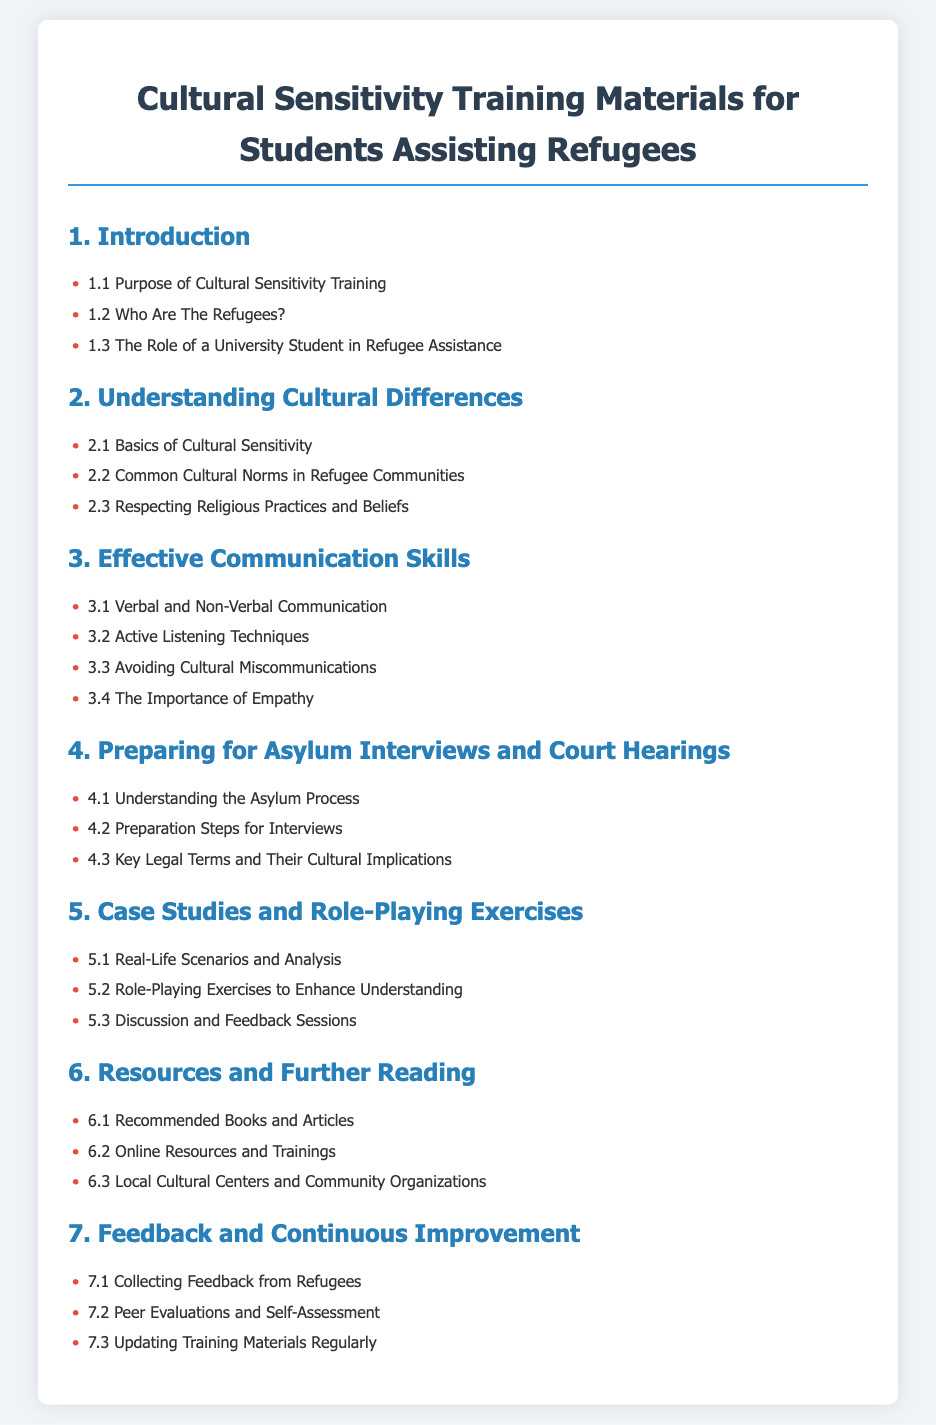What is the title of the document? The title is the heading of the document that indicates its main focus, which is Cultural Sensitivity Training Materials for Students Assisting Refugees.
Answer: Cultural Sensitivity Training Materials for Students Assisting Refugees How many sections are in the Table of Contents? The number of sections is determined by counting the main headings listed in the Table of Contents. There are seven main sections.
Answer: 7 What is the first subsection under Section 1? The first subsection is the initial topic addressed under the introductory section, which outlines the purpose of cultural sensitivity training.
Answer: Purpose of Cultural Sensitivity Training What is the main topic of Section 3? The main topic of Section 3 focuses on skills essential for interacting with refugees, emphasizing clear communication.
Answer: Effective Communication Skills Which section discusses the asylum process? This section specifically addresses the procedural aspect of refugee assistance, emphasizing preparation for legal interviews.
Answer: Preparing for Asylum Interviews and Court Hearings What is one type of exercise mentioned in Section 5? This exercise aims to simulate real-life scenarios to practice handling cultural sensitivity in context.
Answer: Role-Playing Exercises to Enhance Understanding What is the last subsection in the document? This is typically the concluding topic related to improving the training process by gathering input from participants.
Answer: Updating Training Materials Regularly 